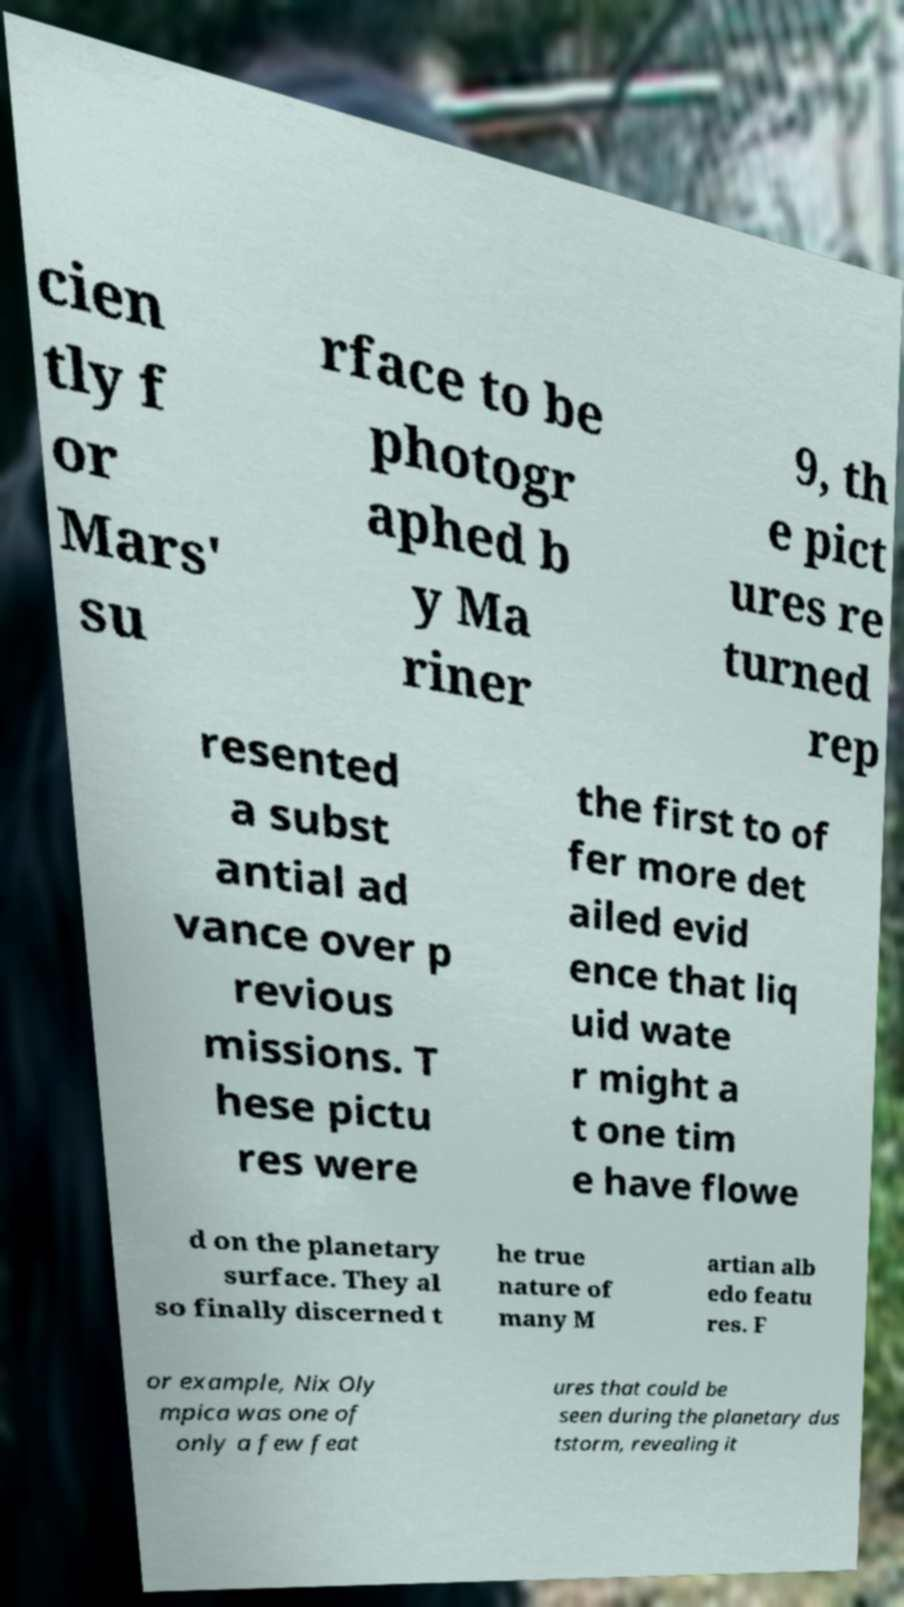Could you extract and type out the text from this image? cien tly f or Mars' su rface to be photogr aphed b y Ma riner 9, th e pict ures re turned rep resented a subst antial ad vance over p revious missions. T hese pictu res were the first to of fer more det ailed evid ence that liq uid wate r might a t one tim e have flowe d on the planetary surface. They al so finally discerned t he true nature of many M artian alb edo featu res. F or example, Nix Oly mpica was one of only a few feat ures that could be seen during the planetary dus tstorm, revealing it 